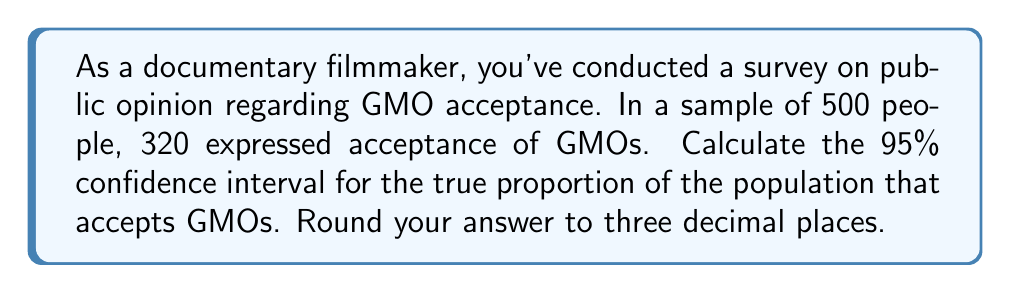Can you answer this question? Let's approach this step-by-step:

1) First, we need to calculate the sample proportion:
   $\hat{p} = \frac{320}{500} = 0.64$

2) The formula for the confidence interval is:
   $$\hat{p} \pm z^* \sqrt{\frac{\hat{p}(1-\hat{p})}{n}}$$
   where $z^*$ is the critical value for the desired confidence level.

3) For a 95% confidence interval, $z^* = 1.96$

4) Now, let's calculate the standard error:
   $$SE = \sqrt{\frac{\hat{p}(1-\hat{p})}{n}} = \sqrt{\frac{0.64(1-0.64)}{500}} = \sqrt{\frac{0.2304}{500}} = 0.0214$$

5) The margin of error is:
   $$ME = z^* \times SE = 1.96 \times 0.0214 = 0.0419$$

6) Therefore, the confidence interval is:
   $$0.64 \pm 0.0419$$

7) This gives us:
   Lower bound: $0.64 - 0.0419 = 0.5981$
   Upper bound: $0.64 + 0.0419 = 0.6819$

8) Rounding to three decimal places:
   $(0.598, 0.682)$
Answer: (0.598, 0.682) 